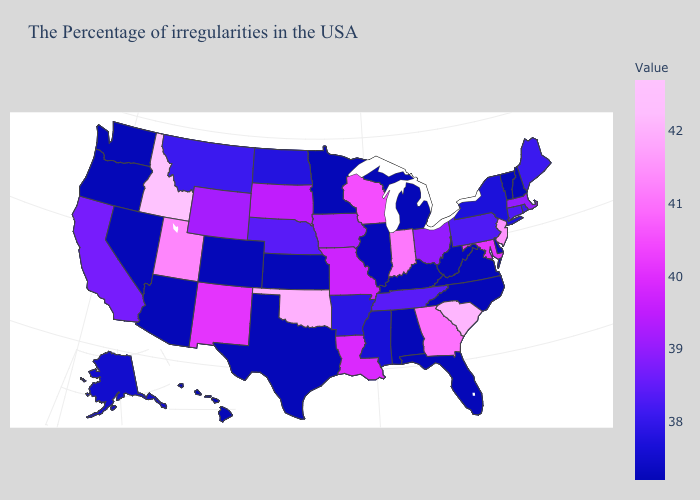Does Idaho have the highest value in the West?
Answer briefly. Yes. Among the states that border South Dakota , which have the lowest value?
Concise answer only. Minnesota. 